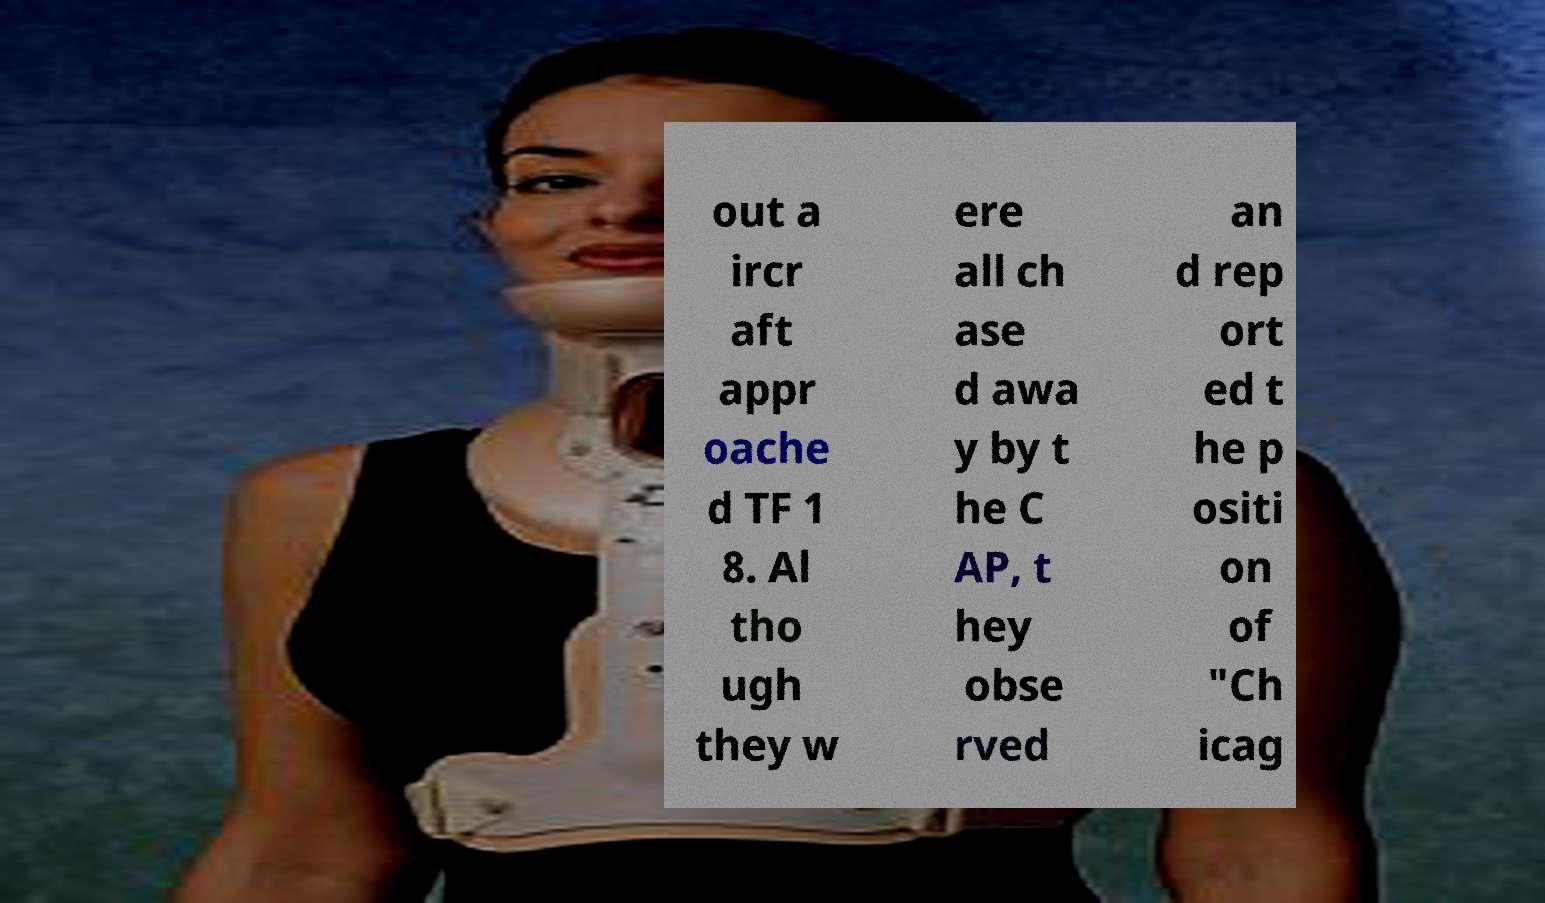Could you assist in decoding the text presented in this image and type it out clearly? out a ircr aft appr oache d TF 1 8. Al tho ugh they w ere all ch ase d awa y by t he C AP, t hey obse rved an d rep ort ed t he p ositi on of "Ch icag 